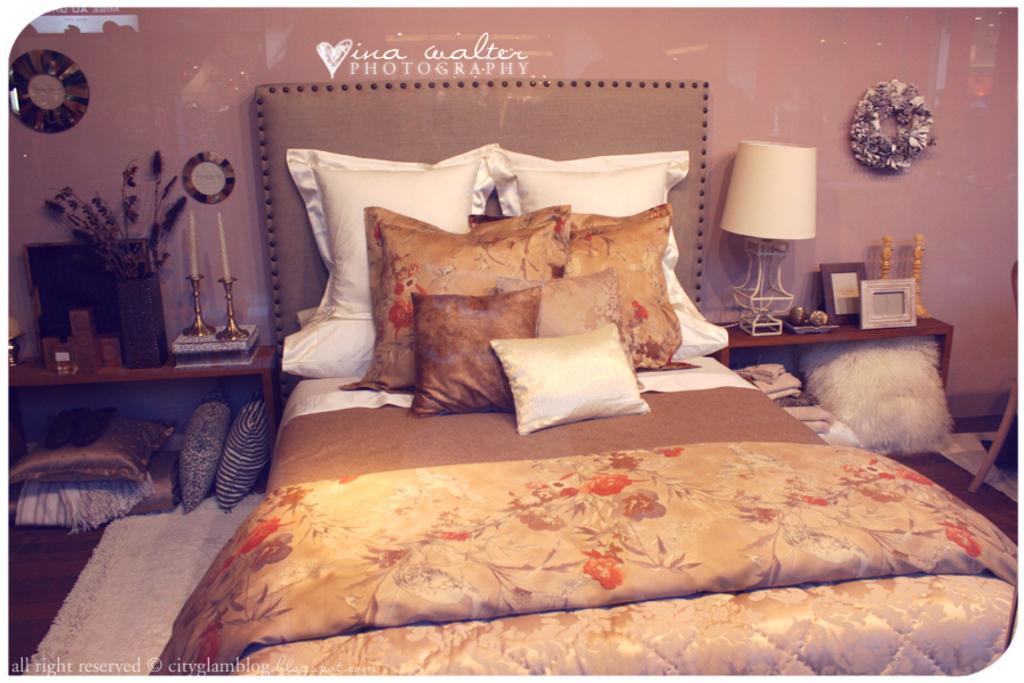Could you give a brief overview of what you see in this image? In this image we can see a bed, blanket, pillows, carpet, tiles, frames, lamp, candles, vase, and objects. In the background we can see wall and decorative items. 